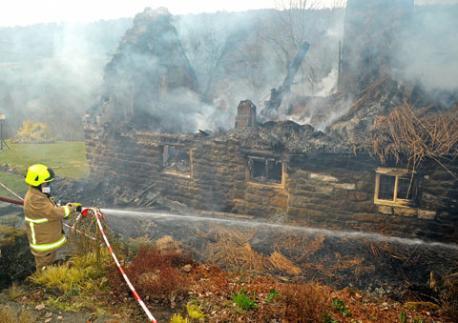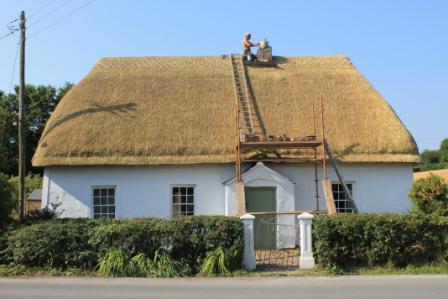The first image is the image on the left, the second image is the image on the right. Given the left and right images, does the statement "One image shows a chimney with a sculptural scalloped border around it, and the other image includes two sets of windows with a thick gray roof that curves around and completely overhangs them." hold true? Answer yes or no. No. The first image is the image on the left, the second image is the image on the right. Assess this claim about the two images: "One of the houses has two chimneys.". Correct or not? Answer yes or no. No. 